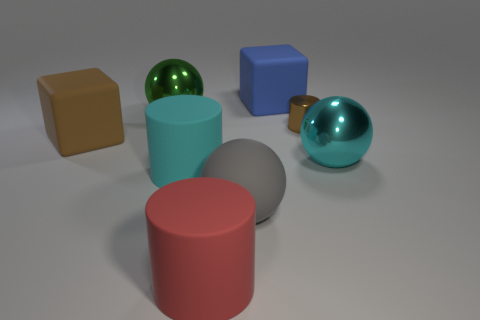Is the number of things that are left of the small metallic cylinder greater than the number of gray spheres that are on the right side of the gray sphere?
Your response must be concise. Yes. There is a matte ball; are there any cylinders behind it?
Ensure brevity in your answer.  Yes. Is there a block of the same size as the cyan shiny ball?
Give a very brief answer. Yes. What color is the tiny thing that is the same material as the big cyan sphere?
Provide a short and direct response. Brown. What is the material of the small object?
Ensure brevity in your answer.  Metal. The large green object is what shape?
Your response must be concise. Sphere. What number of cubes are the same color as the shiny cylinder?
Your answer should be very brief. 1. There is a big sphere that is behind the tiny cylinder that is on the right side of the large green shiny sphere behind the gray sphere; what is it made of?
Offer a terse response. Metal. What number of red things are metal things or large metallic things?
Offer a very short reply. 0. How big is the metallic sphere left of the large metallic thing on the right side of the metal ball on the left side of the large blue thing?
Offer a very short reply. Large. 